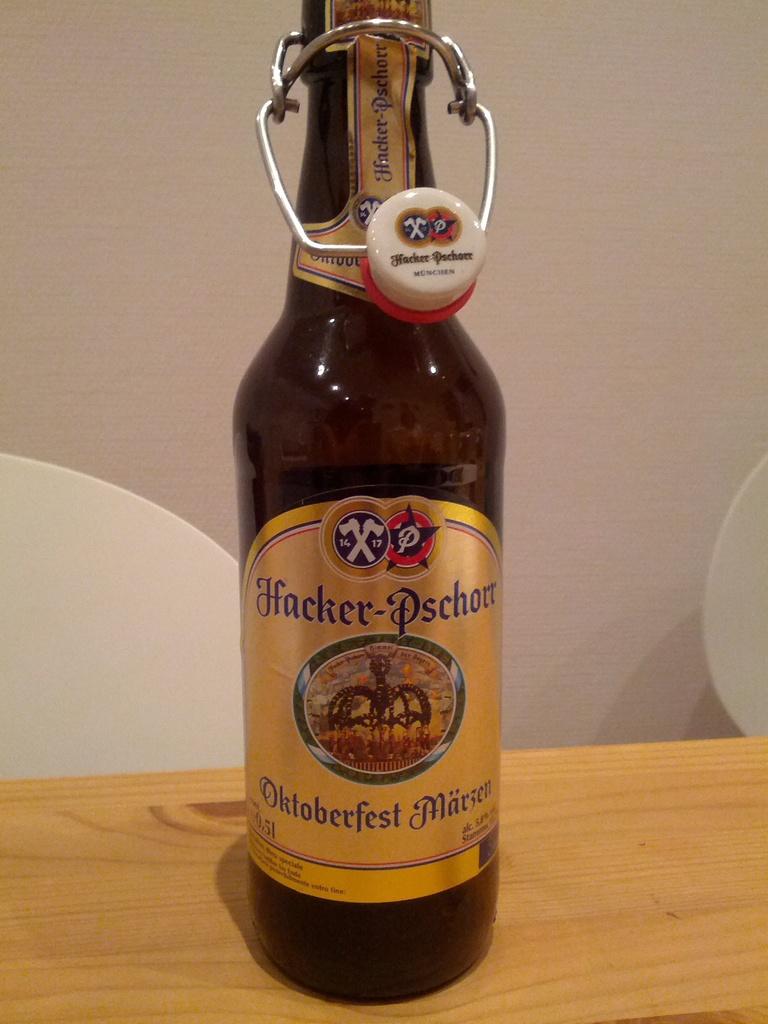What brand is the beer?
Provide a short and direct response. Hacker-pschorr. What is the brand of beer?
Provide a short and direct response. Hacker-pschorr. 